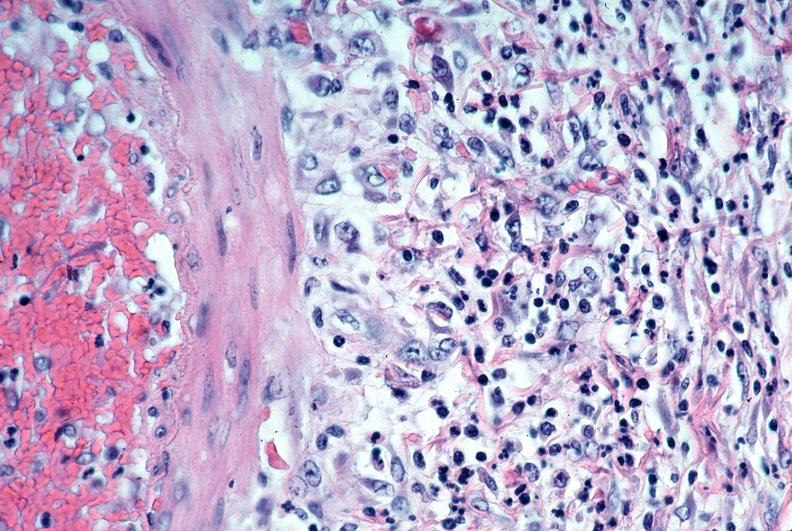does this image show vasculitis, polyarteritis nodosa?
Answer the question using a single word or phrase. Yes 